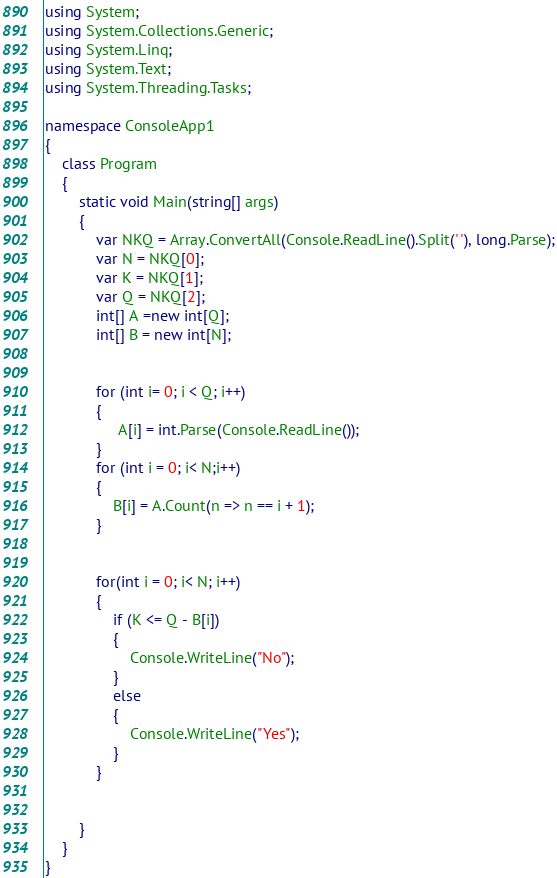Convert code to text. <code><loc_0><loc_0><loc_500><loc_500><_C#_>using System;
using System.Collections.Generic;
using System.Linq;
using System.Text;
using System.Threading.Tasks;
 
namespace ConsoleApp1
{
    class Program
    {
        static void Main(string[] args)
        {
            var NKQ = Array.ConvertAll(Console.ReadLine().Split(' '), long.Parse);
            var N = NKQ[0];
            var K = NKQ[1];
            var Q = NKQ[2];
            int[] A =new int[Q];
            int[] B = new int[N];
 
 
            for (int i= 0; i < Q; i++)
            {
                 A[i] = int.Parse(Console.ReadLine());
            }
            for (int i = 0; i< N;i++)
            {
                B[i] = A.Count(n => n == i + 1);
            }
 
 
            for(int i = 0; i< N; i++)
            {
                if (K <= Q - B[i])
                {
                    Console.WriteLine("No");
                }
                else
                {
                    Console.WriteLine("Yes");
                }
            }
 
 
        }
    }
}</code> 